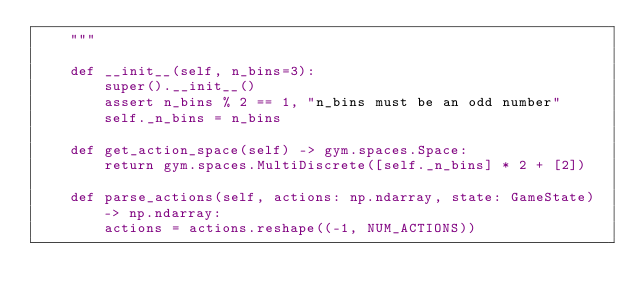<code> <loc_0><loc_0><loc_500><loc_500><_Python_>    """

    def __init__(self, n_bins=3):
        super().__init__()
        assert n_bins % 2 == 1, "n_bins must be an odd number"
        self._n_bins = n_bins

    def get_action_space(self) -> gym.spaces.Space:
        return gym.spaces.MultiDiscrete([self._n_bins] * 2 + [2])

    def parse_actions(self, actions: np.ndarray, state: GameState) -> np.ndarray:
        actions = actions.reshape((-1, NUM_ACTIONS))
</code> 